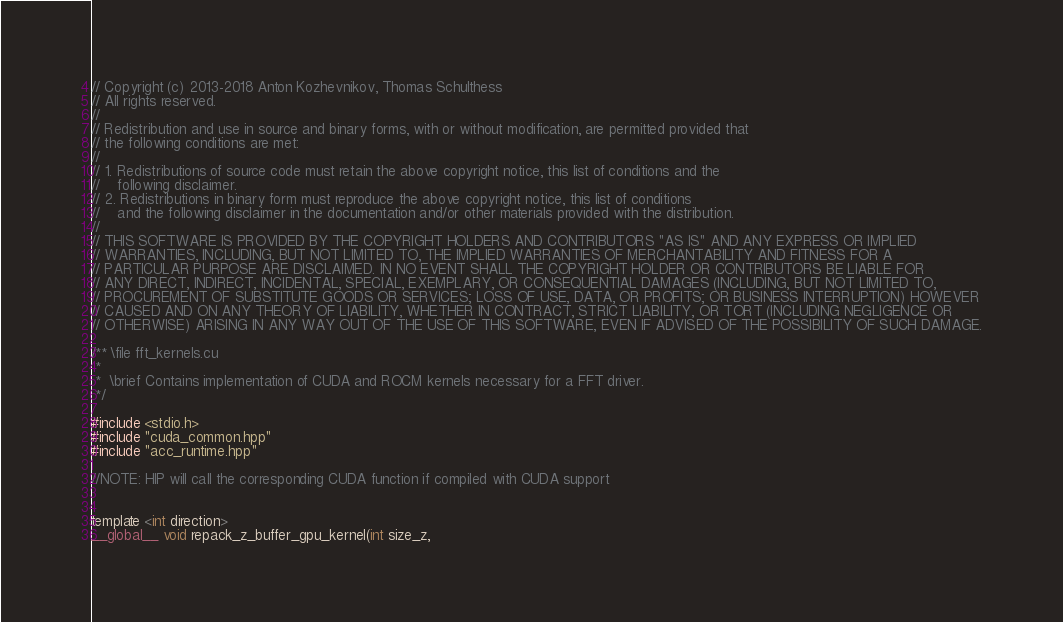<code> <loc_0><loc_0><loc_500><loc_500><_Cuda_>// Copyright (c) 2013-2018 Anton Kozhevnikov, Thomas Schulthess
// All rights reserved.
//
// Redistribution and use in source and binary forms, with or without modification, are permitted provided that
// the following conditions are met:
//
// 1. Redistributions of source code must retain the above copyright notice, this list of conditions and the
//    following disclaimer.
// 2. Redistributions in binary form must reproduce the above copyright notice, this list of conditions
//    and the following disclaimer in the documentation and/or other materials provided with the distribution.
//
// THIS SOFTWARE IS PROVIDED BY THE COPYRIGHT HOLDERS AND CONTRIBUTORS "AS IS" AND ANY EXPRESS OR IMPLIED
// WARRANTIES, INCLUDING, BUT NOT LIMITED TO, THE IMPLIED WARRANTIES OF MERCHANTABILITY AND FITNESS FOR A
// PARTICULAR PURPOSE ARE DISCLAIMED. IN NO EVENT SHALL THE COPYRIGHT HOLDER OR CONTRIBUTORS BE LIABLE FOR
// ANY DIRECT, INDIRECT, INCIDENTAL, SPECIAL, EXEMPLARY, OR CONSEQUENTIAL DAMAGES (INCLUDING, BUT NOT LIMITED TO,
// PROCUREMENT OF SUBSTITUTE GOODS OR SERVICES; LOSS OF USE, DATA, OR PROFITS; OR BUSINESS INTERRUPTION) HOWEVER
// CAUSED AND ON ANY THEORY OF LIABILITY, WHETHER IN CONTRACT, STRICT LIABILITY, OR TORT (INCLUDING NEGLIGENCE OR
// OTHERWISE) ARISING IN ANY WAY OUT OF THE USE OF THIS SOFTWARE, EVEN IF ADVISED OF THE POSSIBILITY OF SUCH DAMAGE.

/** \file fft_kernels.cu
 *
 *  \brief Contains implementation of CUDA and ROCM kernels necessary for a FFT driver.
 */

#include <stdio.h>
#include "cuda_common.hpp"
#include "acc_runtime.hpp"

//NOTE: HIP will call the corresponding CUDA function if compiled with CUDA support


template <int direction>
__global__ void repack_z_buffer_gpu_kernel(int size_z,</code> 